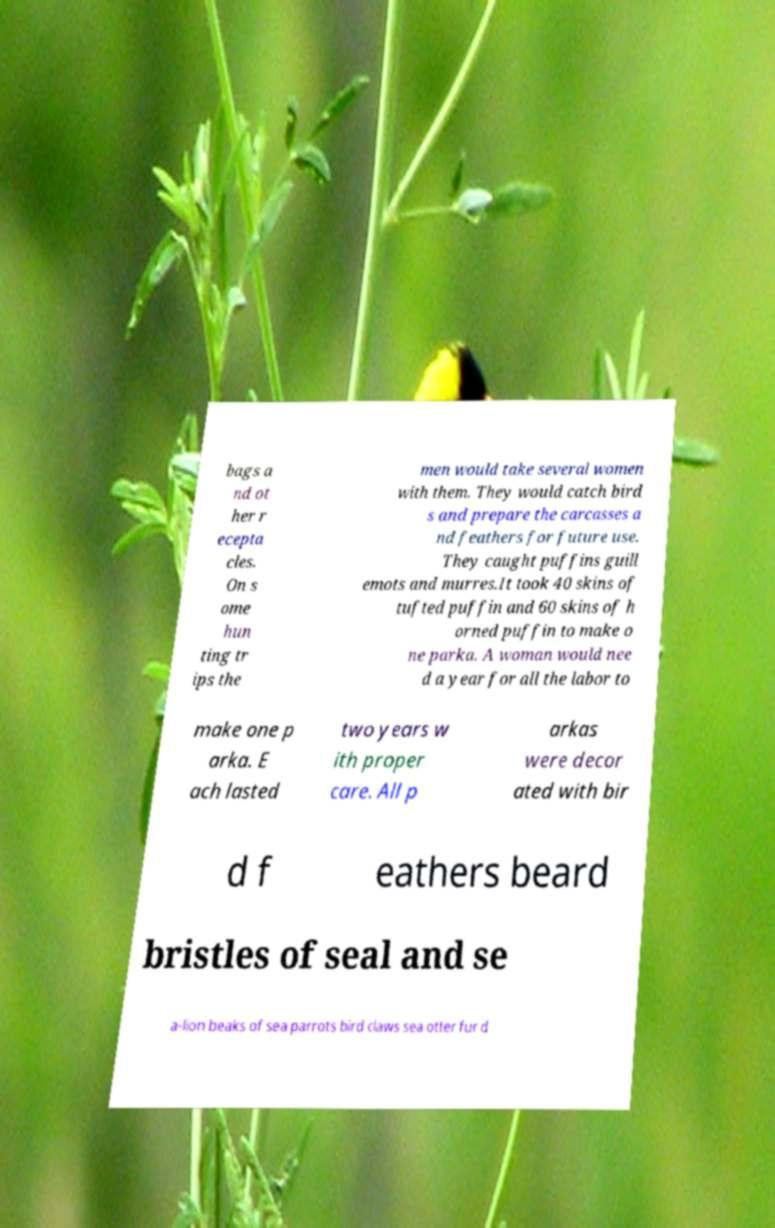Could you extract and type out the text from this image? bags a nd ot her r ecepta cles. On s ome hun ting tr ips the men would take several women with them. They would catch bird s and prepare the carcasses a nd feathers for future use. They caught puffins guill emots and murres.It took 40 skins of tufted puffin and 60 skins of h orned puffin to make o ne parka. A woman would nee d a year for all the labor to make one p arka. E ach lasted two years w ith proper care. All p arkas were decor ated with bir d f eathers beard bristles of seal and se a-lion beaks of sea parrots bird claws sea otter fur d 